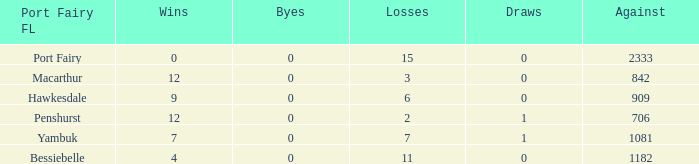How many wins for Port Fairy and against more than 2333? None. 